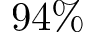<formula> <loc_0><loc_0><loc_500><loc_500>9 4 \%</formula> 